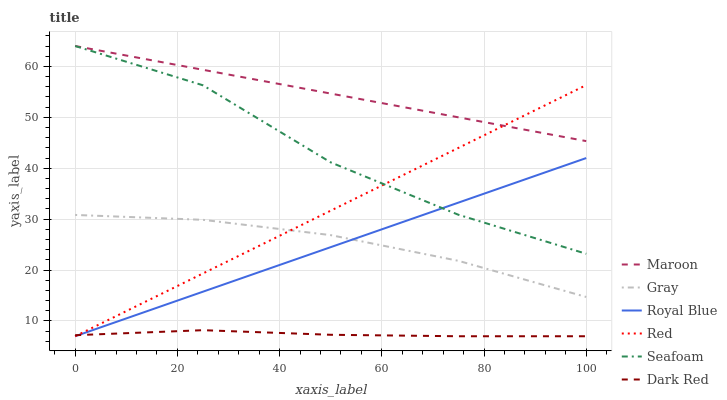Does Dark Red have the minimum area under the curve?
Answer yes or no. Yes. Does Maroon have the maximum area under the curve?
Answer yes or no. Yes. Does Seafoam have the minimum area under the curve?
Answer yes or no. No. Does Seafoam have the maximum area under the curve?
Answer yes or no. No. Is Red the smoothest?
Answer yes or no. Yes. Is Seafoam the roughest?
Answer yes or no. Yes. Is Dark Red the smoothest?
Answer yes or no. No. Is Dark Red the roughest?
Answer yes or no. No. Does Dark Red have the lowest value?
Answer yes or no. Yes. Does Seafoam have the lowest value?
Answer yes or no. No. Does Maroon have the highest value?
Answer yes or no. Yes. Does Dark Red have the highest value?
Answer yes or no. No. Is Dark Red less than Maroon?
Answer yes or no. Yes. Is Maroon greater than Dark Red?
Answer yes or no. Yes. Does Royal Blue intersect Seafoam?
Answer yes or no. Yes. Is Royal Blue less than Seafoam?
Answer yes or no. No. Is Royal Blue greater than Seafoam?
Answer yes or no. No. Does Dark Red intersect Maroon?
Answer yes or no. No. 